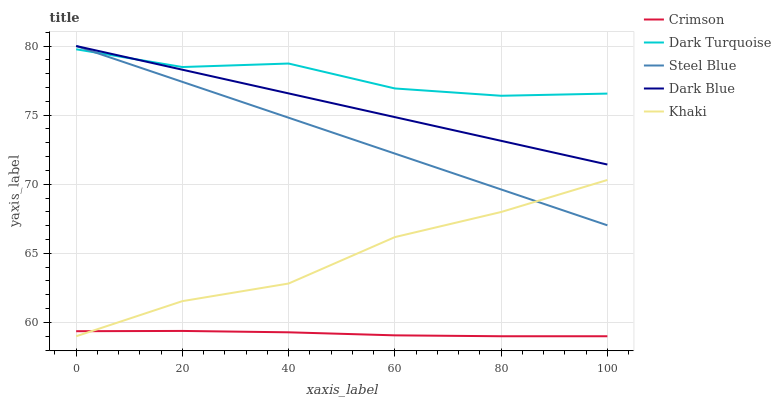Does Crimson have the minimum area under the curve?
Answer yes or no. Yes. Does Dark Turquoise have the maximum area under the curve?
Answer yes or no. Yes. Does Khaki have the minimum area under the curve?
Answer yes or no. No. Does Khaki have the maximum area under the curve?
Answer yes or no. No. Is Steel Blue the smoothest?
Answer yes or no. Yes. Is Dark Turquoise the roughest?
Answer yes or no. Yes. Is Khaki the smoothest?
Answer yes or no. No. Is Khaki the roughest?
Answer yes or no. No. Does Crimson have the lowest value?
Answer yes or no. Yes. Does Dark Turquoise have the lowest value?
Answer yes or no. No. Does Dark Blue have the highest value?
Answer yes or no. Yes. Does Dark Turquoise have the highest value?
Answer yes or no. No. Is Crimson less than Dark Turquoise?
Answer yes or no. Yes. Is Dark Turquoise greater than Crimson?
Answer yes or no. Yes. Does Khaki intersect Steel Blue?
Answer yes or no. Yes. Is Khaki less than Steel Blue?
Answer yes or no. No. Is Khaki greater than Steel Blue?
Answer yes or no. No. Does Crimson intersect Dark Turquoise?
Answer yes or no. No. 